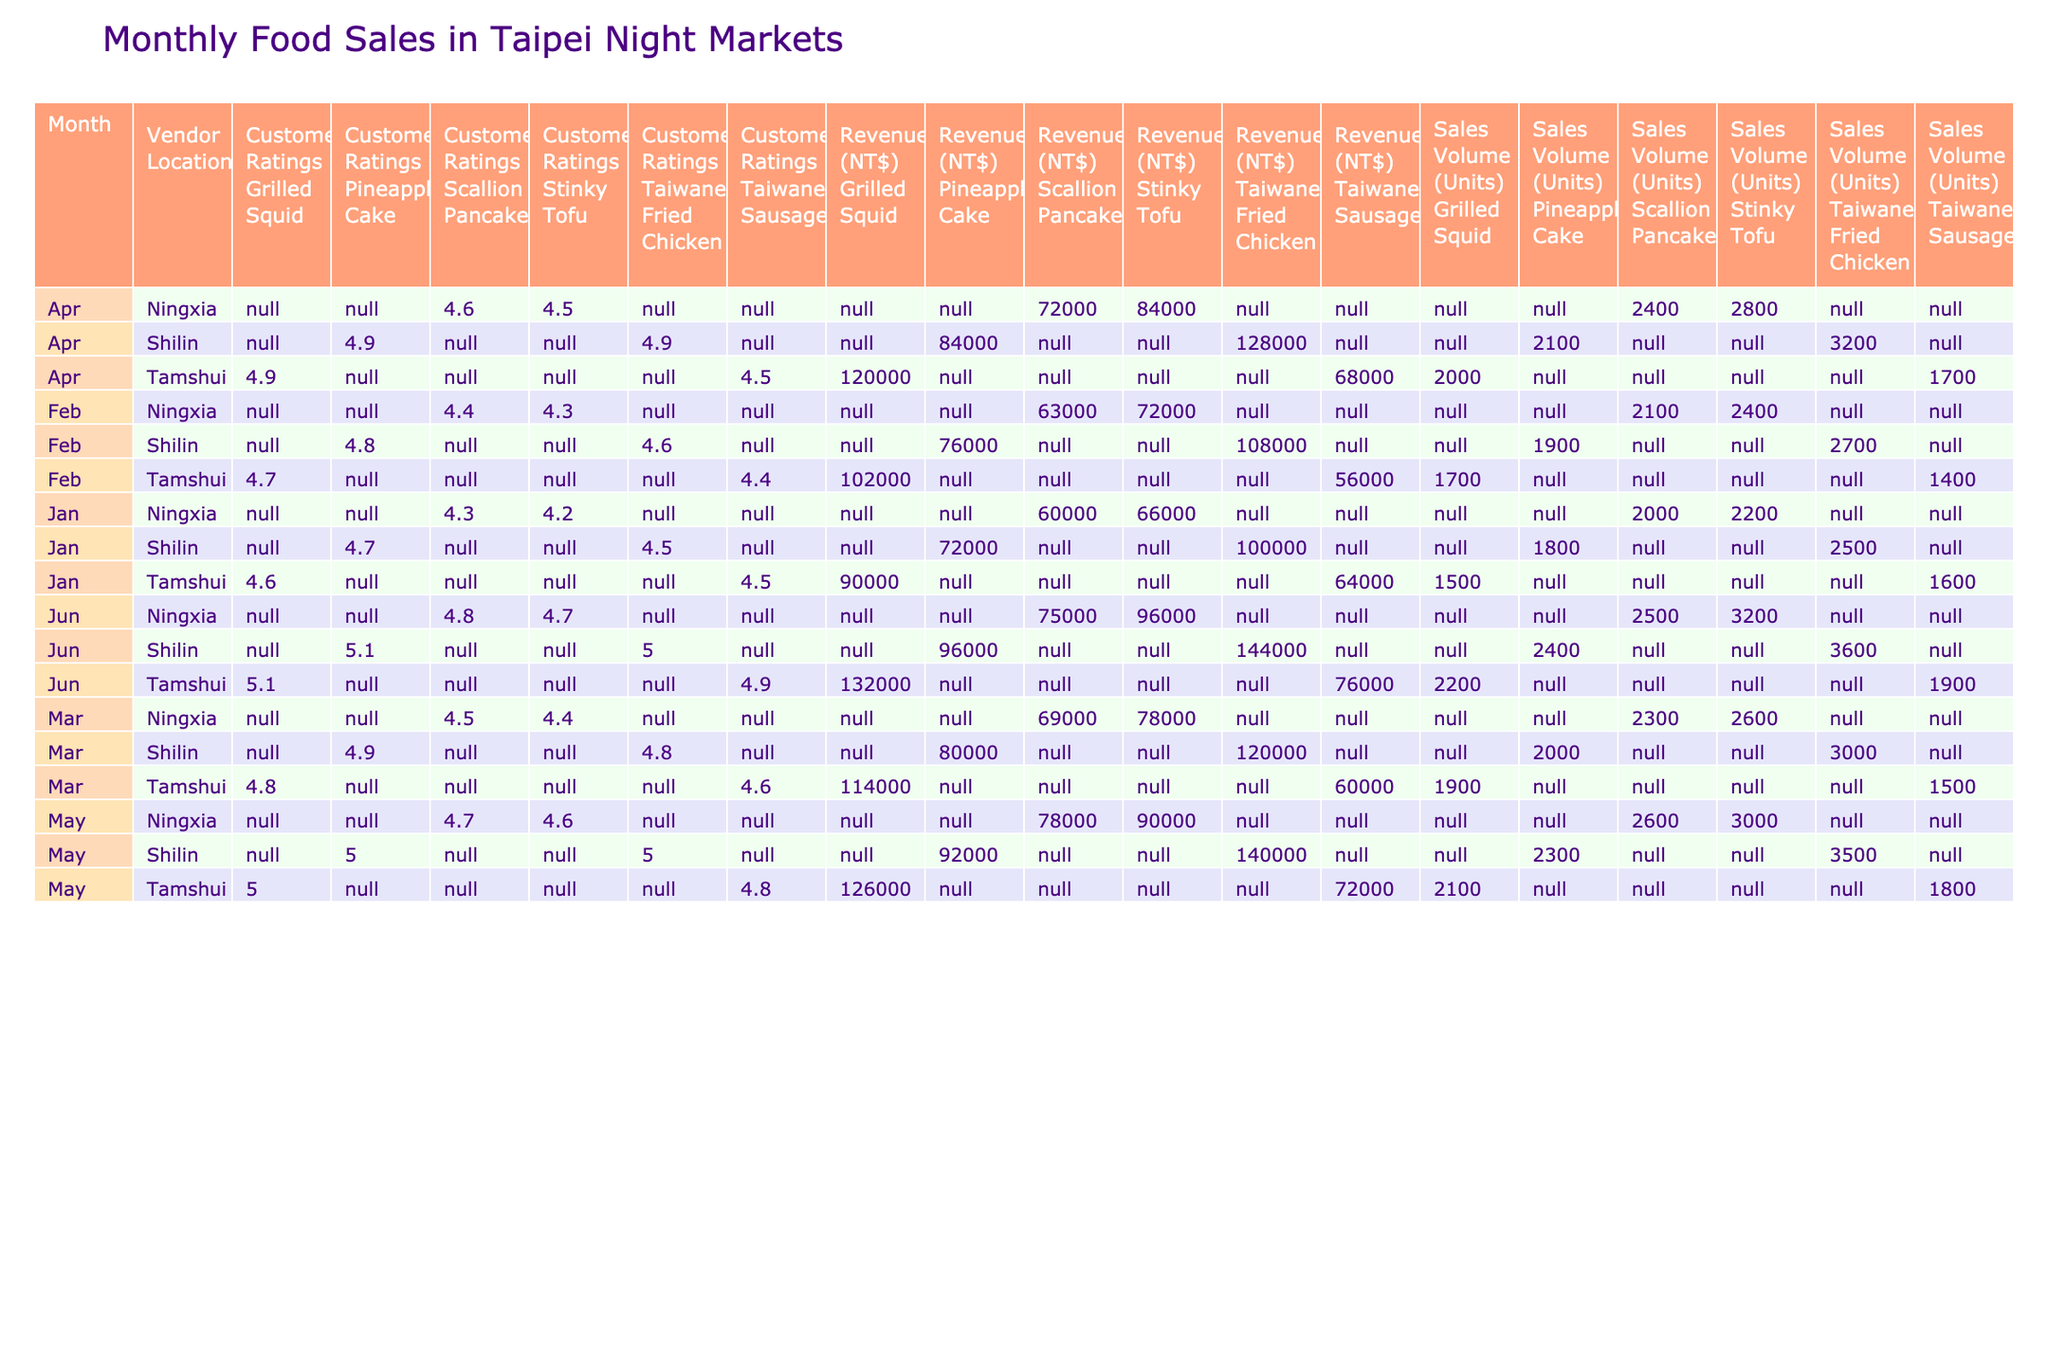What food item had the highest sales volume in May? In May, the highest sales volume from the food items listed is 3500 units for Taiwanese Fried Chicken at Shilin Night Market.
Answer: 3500 units Which vendor had the highest revenue in April? In April, the highest revenue was NT$128,000 from the Taiwanese Fried Chicken at Shilin Night Market.
Answer: NT$128,000 How many total units of food were sold across all vendors in June? Adding up the sales volumes for June: 3600 (Fried Chicken) + 2400 (Pineapple Cake) + 3200 (Stinky Tofu) + 2500 (Scallion Pancake) + 2200 (Grilled Squid) + 1900 (Sausage) = 18,300 units.
Answer: 18300 units What is the average customer rating for the Stinky Tofu across all months? The customer ratings for Stinky Tofu are 4.2 (January), 4.3 (February), 4.4 (March), 4.5 (April), and 4.6 (May), adding them gives 22.0, and dividing by 5 gives an average rating of 4.4.
Answer: 4.4 Did the sales volume for Pineapple Cake increase every month? The sales volumes for Pineapple Cake are 1800 (January), 1900 (February), 2000 (March), 2100 (April), and 2300 (May), showing a consistent increase every month.
Answer: Yes What was the month with the lowest customer rating for Taiwanese Sausage, and what was the rating? The ratings for Taiwanese Sausage are 4.5 (January), 4.4 (February), 4.6 (March), 4.5 (April), and 4.8 (May). The lowest rating occurred in February at 4.4.
Answer: February, 4.4 Which night market sold the most food items across all months? Summing the units sold at each night market: Shilin Night Market (sum of sales from all months = 15,600 units), Ningxia Night Market (13,500 units), and Tamshui Night Market (12,100 units). Shilin Night Market has the highest units sold.
Answer: Shilin Night Market What was the revenue difference between the Grilled Squid in January and in June? The revenue for Grilled Squid in January is NT$90,000, while in June it is NT$132,000. The difference is NT$132,000 - NT$90,000 = NT$42,000.
Answer: NT$42,000 What food item consistently received a customer rating above 4.7 every month? Analyzing the ratings, Taiwanese Fried Chicken received ratings of 4.5, 4.6, 4.8, 4.9, and 5.0, consistently above 4.7 from February.
Answer: Yes, from February How many units of Stinky Tofu were sold across all months? Summing the sales volumes of Stinky Tofu: 2200 (January) + 2400 (February) + 2600 (March) + 2800 (April) + 3000 (May) + 3200 (June) gives a total of 16,200 units.
Answer: 16200 units 